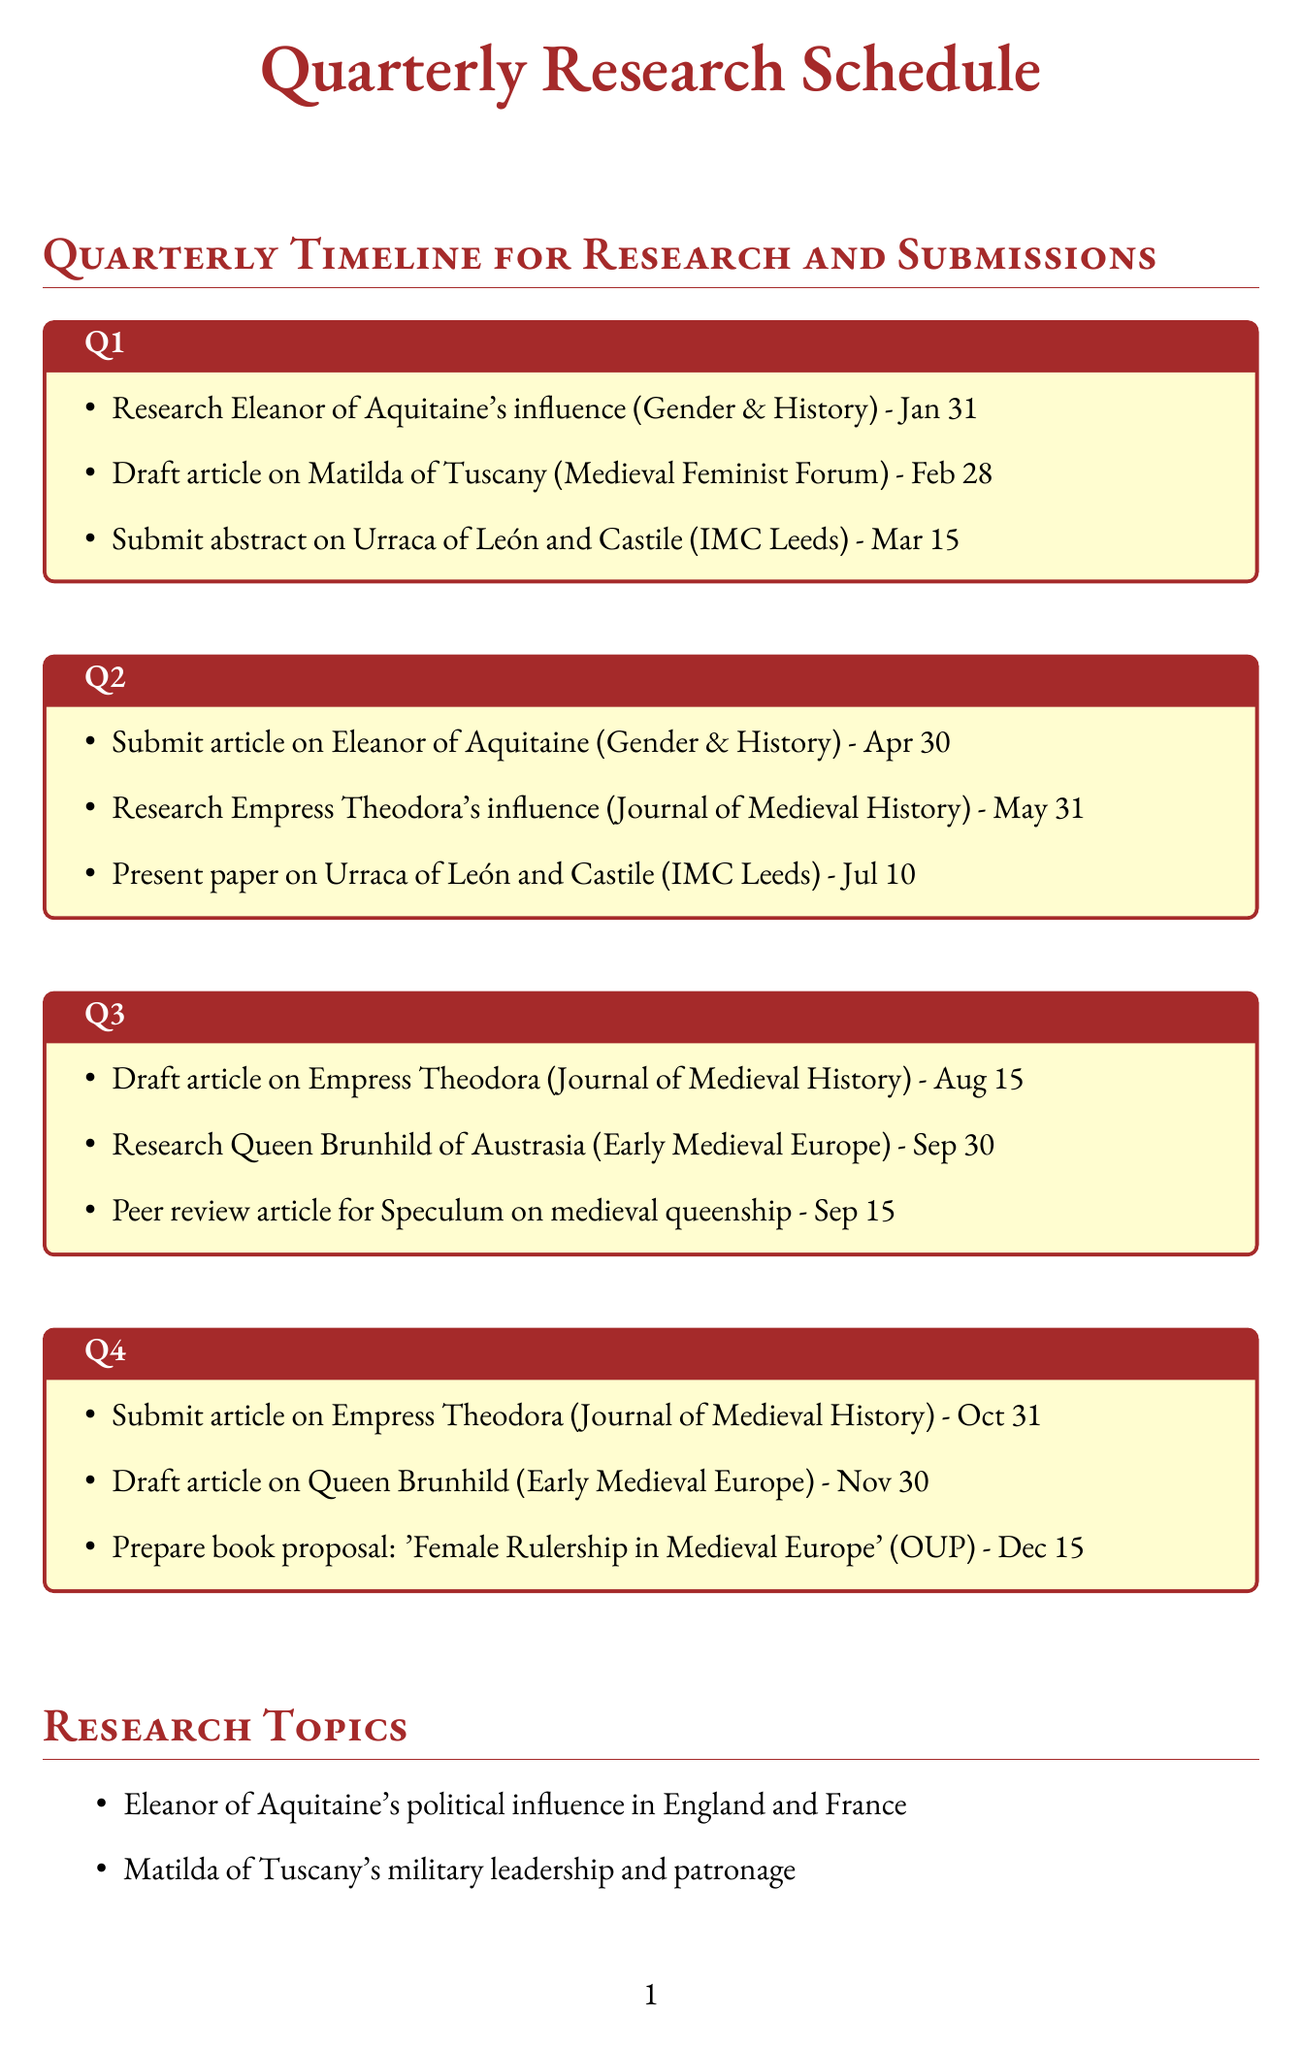What is the first task in Q1? The first task in Q1 is to research Eleanor of Aquitaine's influence in England and France.
Answer: Research Eleanor of Aquitaine's influence in England and France What is the deadline to submit the article on Empress Theodora? The deadline to submit the article on Empress Theodora is October 31.
Answer: October 31 Which journal will the article on Matilda of Tuscany be submitted to? The article on Matilda of Tuscany will be submitted to Medieval Feminist Forum.
Answer: Medieval Feminist Forum How many activities are planned for Q3? There are three activities planned for Q3 as listed in the quarterly schedule.
Answer: 3 What is the title of the book proposal mentioned in Q4? The title of the book proposal mentioned in Q4 is 'Female Rulership in Medieval Europe'.
Answer: 'Female Rulership in Medieval Europe' Which conference is associated with Urraca of León and Castile? The conference associated with Urraca of León and Castile is the International Medieval Congress, Leeds.
Answer: International Medieval Congress, Leeds What type of analysis is mentioned as a research method? The analysis mentioned as a research method is comparative analysis of primary sources.
Answer: Comparative analysis of primary sources Who is the last female ruler listed in the research topics? The last female ruler listed in the research topics is Queen Brunhild of Austrasia.
Answer: Queen Brunhild of Austrasia 